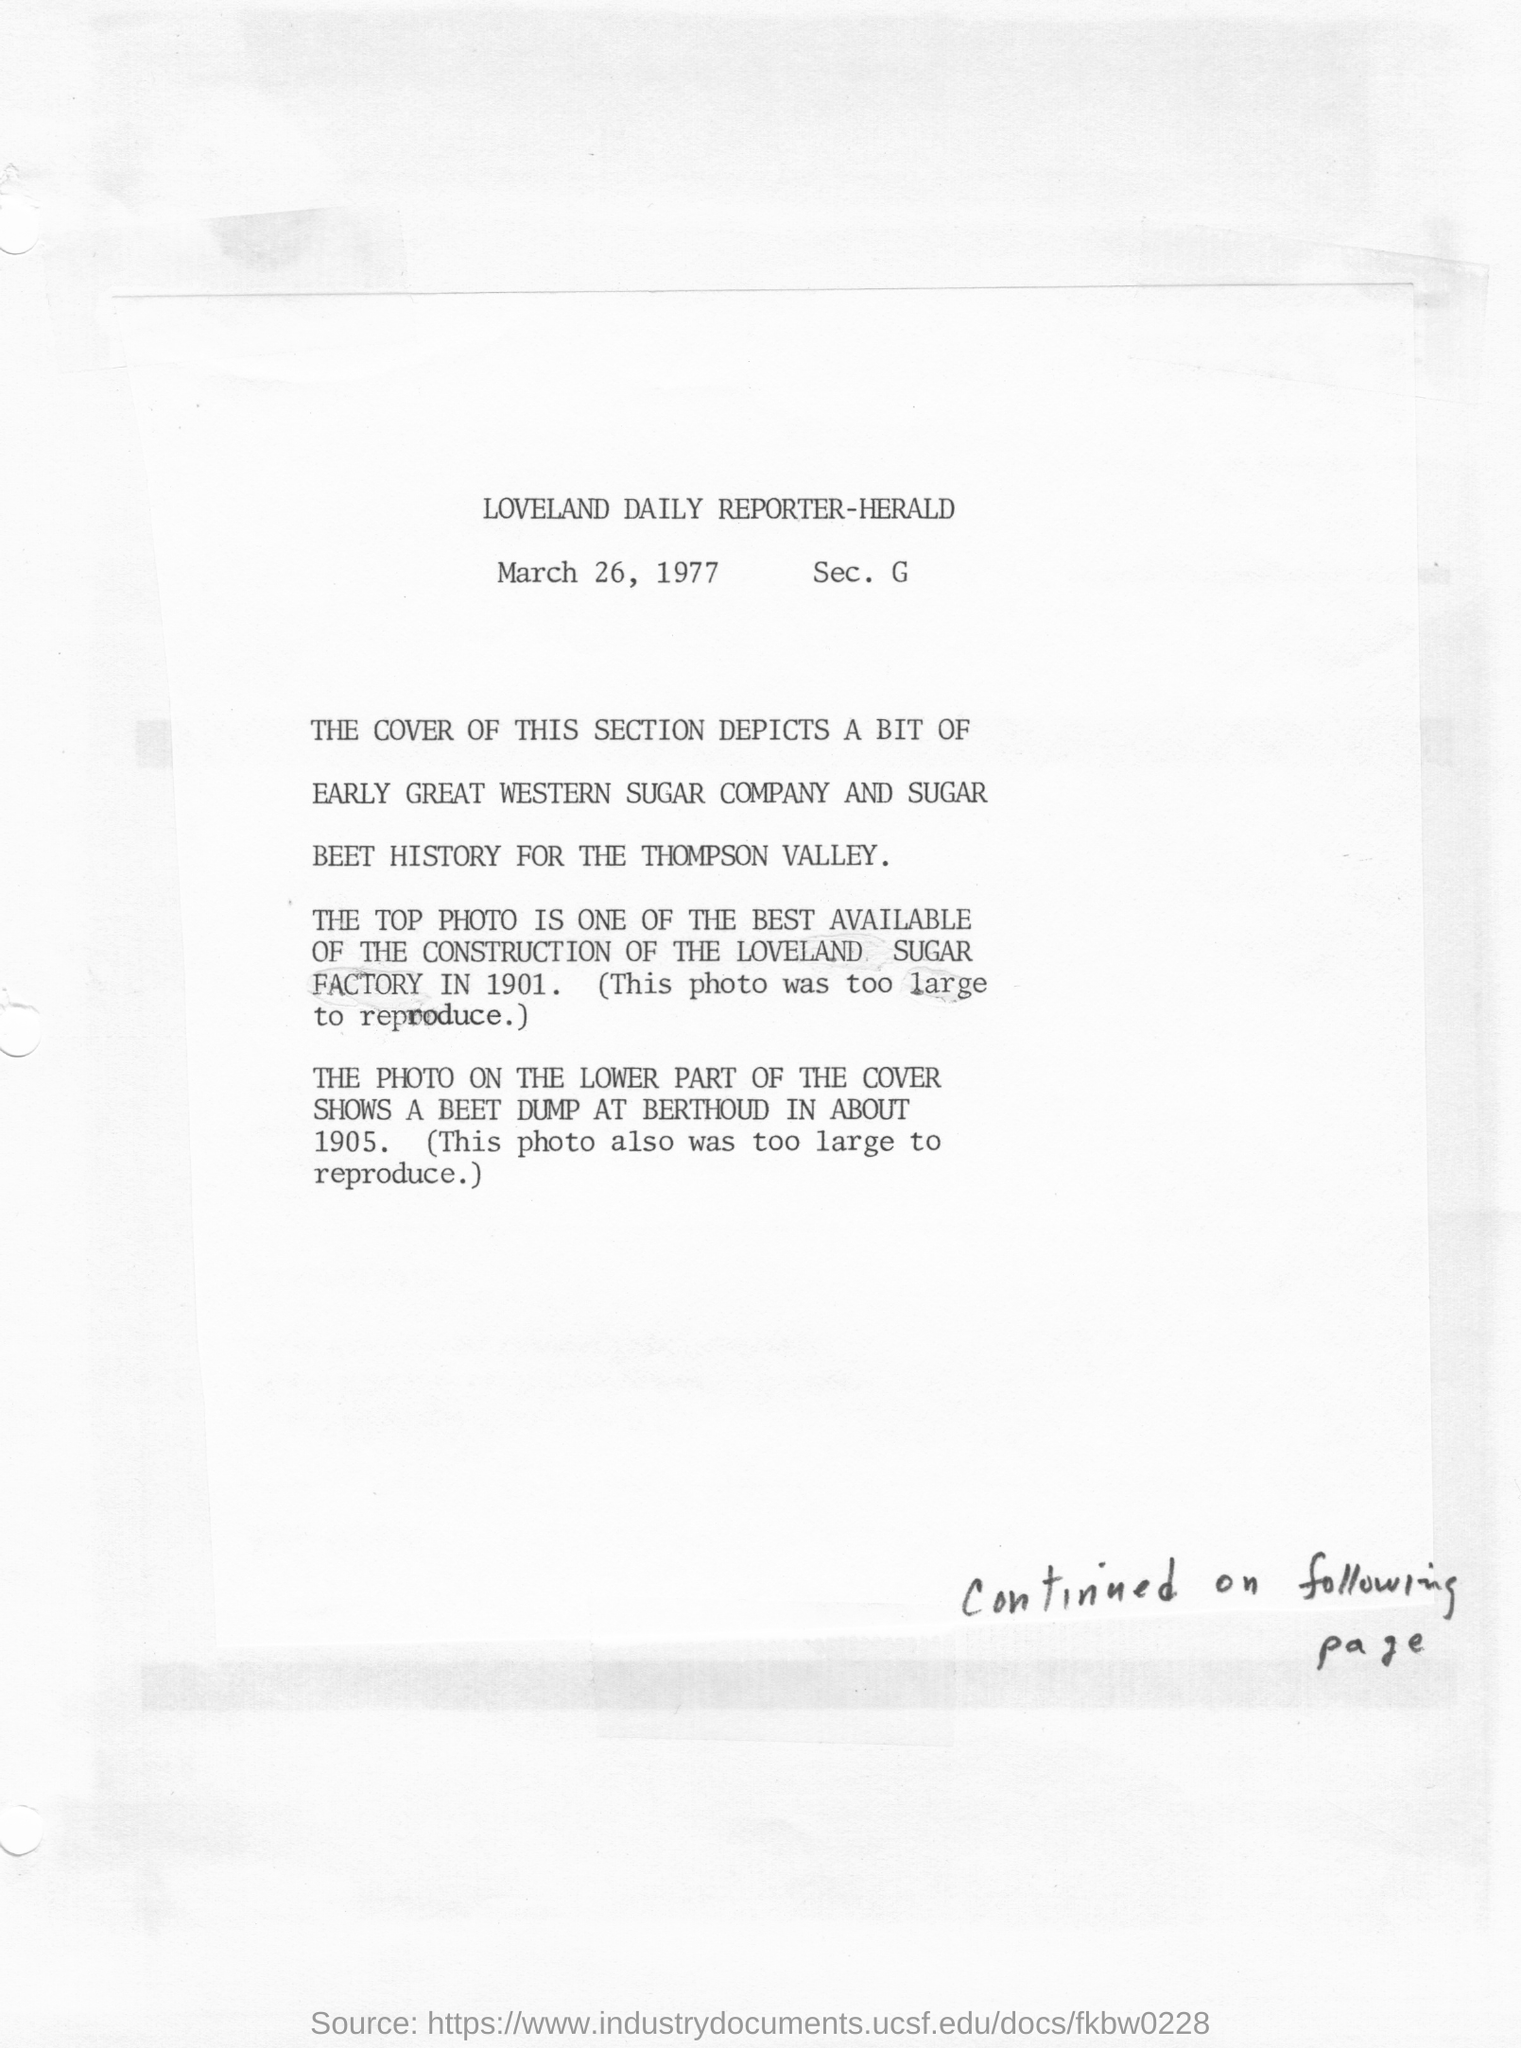Mention a couple of crucial points in this snapshot. The article in question was published on March 26, 1977. 